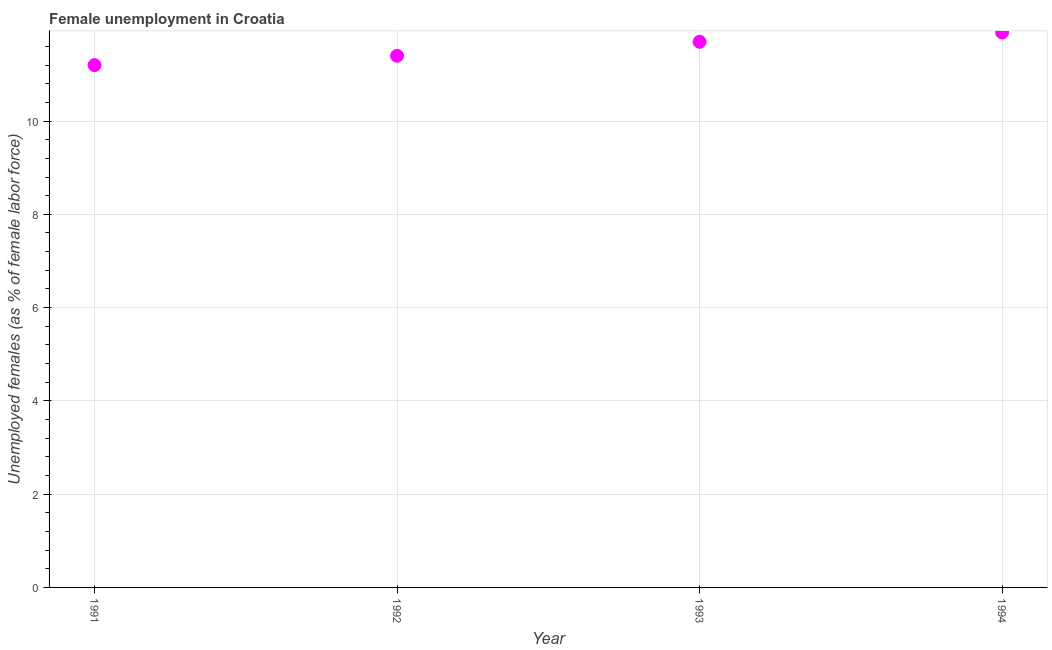What is the unemployed females population in 1991?
Offer a terse response. 11.2. Across all years, what is the maximum unemployed females population?
Make the answer very short. 11.9. Across all years, what is the minimum unemployed females population?
Ensure brevity in your answer.  11.2. In which year was the unemployed females population maximum?
Your answer should be compact. 1994. What is the sum of the unemployed females population?
Offer a terse response. 46.2. What is the difference between the unemployed females population in 1992 and 1994?
Give a very brief answer. -0.5. What is the average unemployed females population per year?
Provide a short and direct response. 11.55. What is the median unemployed females population?
Provide a succinct answer. 11.55. In how many years, is the unemployed females population greater than 9.6 %?
Provide a succinct answer. 4. What is the ratio of the unemployed females population in 1992 to that in 1993?
Provide a short and direct response. 0.97. Is the unemployed females population in 1991 less than that in 1993?
Your response must be concise. Yes. What is the difference between the highest and the second highest unemployed females population?
Make the answer very short. 0.2. Is the sum of the unemployed females population in 1992 and 1994 greater than the maximum unemployed females population across all years?
Your answer should be compact. Yes. What is the difference between the highest and the lowest unemployed females population?
Offer a very short reply. 0.7. In how many years, is the unemployed females population greater than the average unemployed females population taken over all years?
Your response must be concise. 2. How many dotlines are there?
Your answer should be very brief. 1. How many years are there in the graph?
Your answer should be very brief. 4. Does the graph contain grids?
Ensure brevity in your answer.  Yes. What is the title of the graph?
Offer a very short reply. Female unemployment in Croatia. What is the label or title of the X-axis?
Ensure brevity in your answer.  Year. What is the label or title of the Y-axis?
Make the answer very short. Unemployed females (as % of female labor force). What is the Unemployed females (as % of female labor force) in 1991?
Offer a very short reply. 11.2. What is the Unemployed females (as % of female labor force) in 1992?
Provide a short and direct response. 11.4. What is the Unemployed females (as % of female labor force) in 1993?
Your answer should be very brief. 11.7. What is the Unemployed females (as % of female labor force) in 1994?
Keep it short and to the point. 11.9. What is the difference between the Unemployed females (as % of female labor force) in 1991 and 1992?
Provide a short and direct response. -0.2. What is the difference between the Unemployed females (as % of female labor force) in 1991 and 1993?
Offer a terse response. -0.5. What is the difference between the Unemployed females (as % of female labor force) in 1992 and 1993?
Your answer should be compact. -0.3. What is the difference between the Unemployed females (as % of female labor force) in 1992 and 1994?
Your answer should be very brief. -0.5. What is the difference between the Unemployed females (as % of female labor force) in 1993 and 1994?
Make the answer very short. -0.2. What is the ratio of the Unemployed females (as % of female labor force) in 1991 to that in 1994?
Offer a very short reply. 0.94. What is the ratio of the Unemployed females (as % of female labor force) in 1992 to that in 1993?
Ensure brevity in your answer.  0.97. What is the ratio of the Unemployed females (as % of female labor force) in 1992 to that in 1994?
Provide a short and direct response. 0.96. What is the ratio of the Unemployed females (as % of female labor force) in 1993 to that in 1994?
Give a very brief answer. 0.98. 